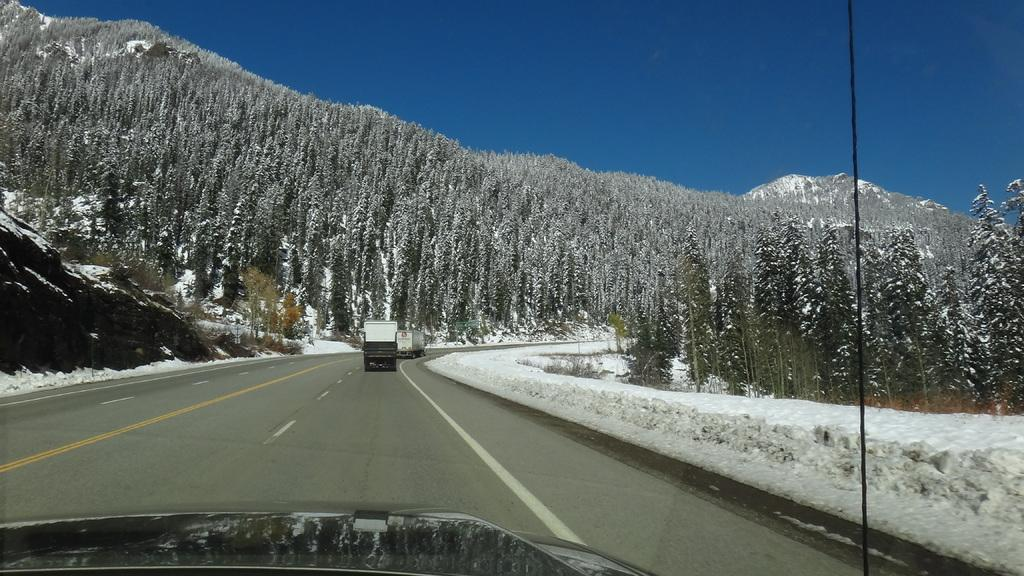What can be seen on the road in the image? There are vehicles on the road in the image. What is the condition of the trees in the background of the image? The trees in the background of the image are covered with snow. What other object can be seen in the background of the image? There is a rock in the background of the image. What type of collar is being worn by the birthday cake in the image? There is no birthday cake or collar present in the image. How many matches are visible in the image? There are no matches present in the image. 